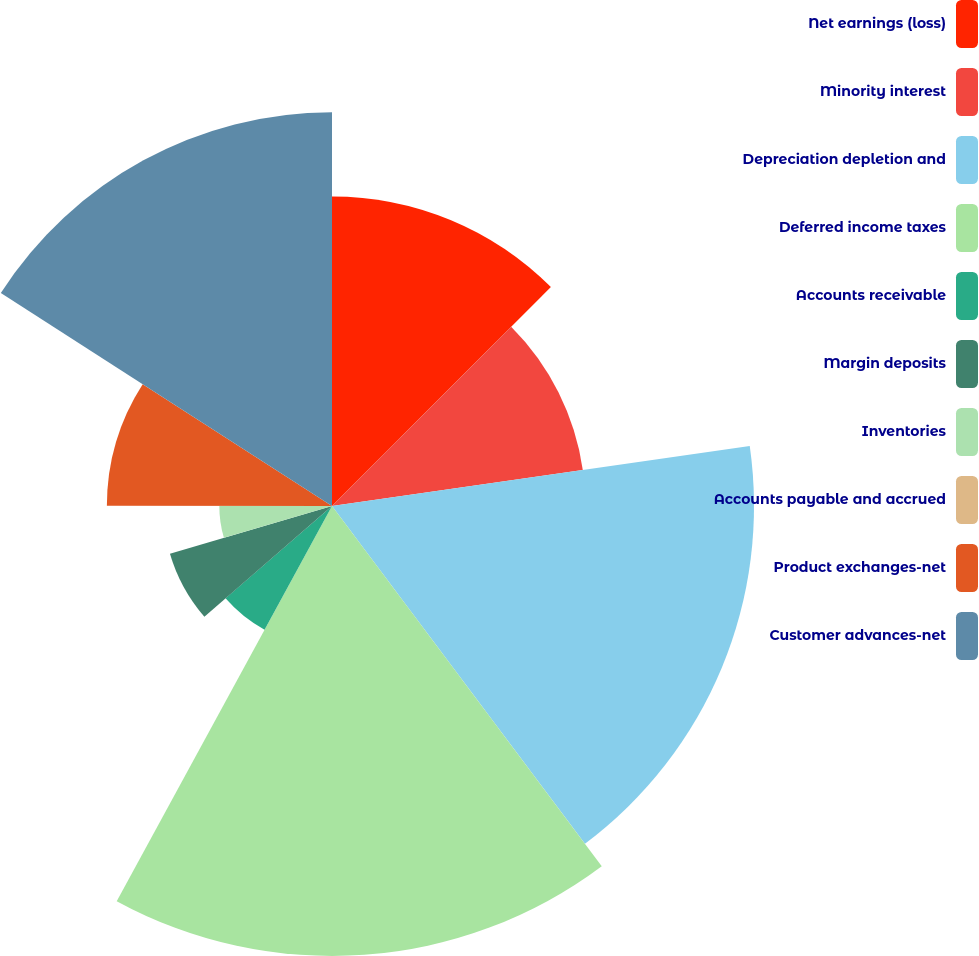Convert chart. <chart><loc_0><loc_0><loc_500><loc_500><pie_chart><fcel>Net earnings (loss)<fcel>Minority interest<fcel>Depreciation depletion and<fcel>Deferred income taxes<fcel>Accounts receivable<fcel>Margin deposits<fcel>Inventories<fcel>Accounts payable and accrued<fcel>Product exchanges-net<fcel>Customer advances-net<nl><fcel>12.5%<fcel>10.23%<fcel>17.04%<fcel>18.17%<fcel>5.69%<fcel>6.82%<fcel>4.55%<fcel>0.01%<fcel>9.09%<fcel>15.9%<nl></chart> 